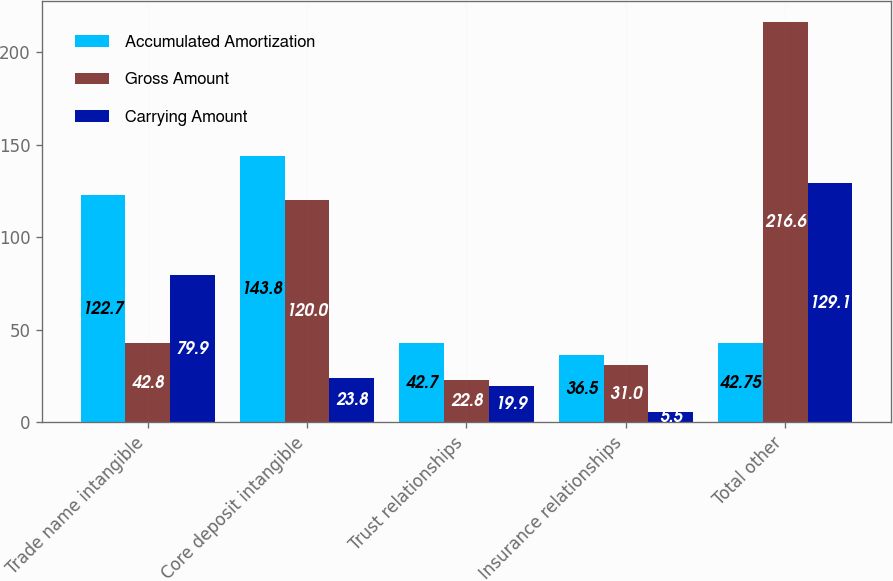Convert chart to OTSL. <chart><loc_0><loc_0><loc_500><loc_500><stacked_bar_chart><ecel><fcel>Trade name intangible<fcel>Core deposit intangible<fcel>Trust relationships<fcel>Insurance relationships<fcel>Total other<nl><fcel>Accumulated Amortization<fcel>122.7<fcel>143.8<fcel>42.7<fcel>36.5<fcel>42.75<nl><fcel>Gross Amount<fcel>42.8<fcel>120<fcel>22.8<fcel>31<fcel>216.6<nl><fcel>Carrying Amount<fcel>79.9<fcel>23.8<fcel>19.9<fcel>5.5<fcel>129.1<nl></chart> 